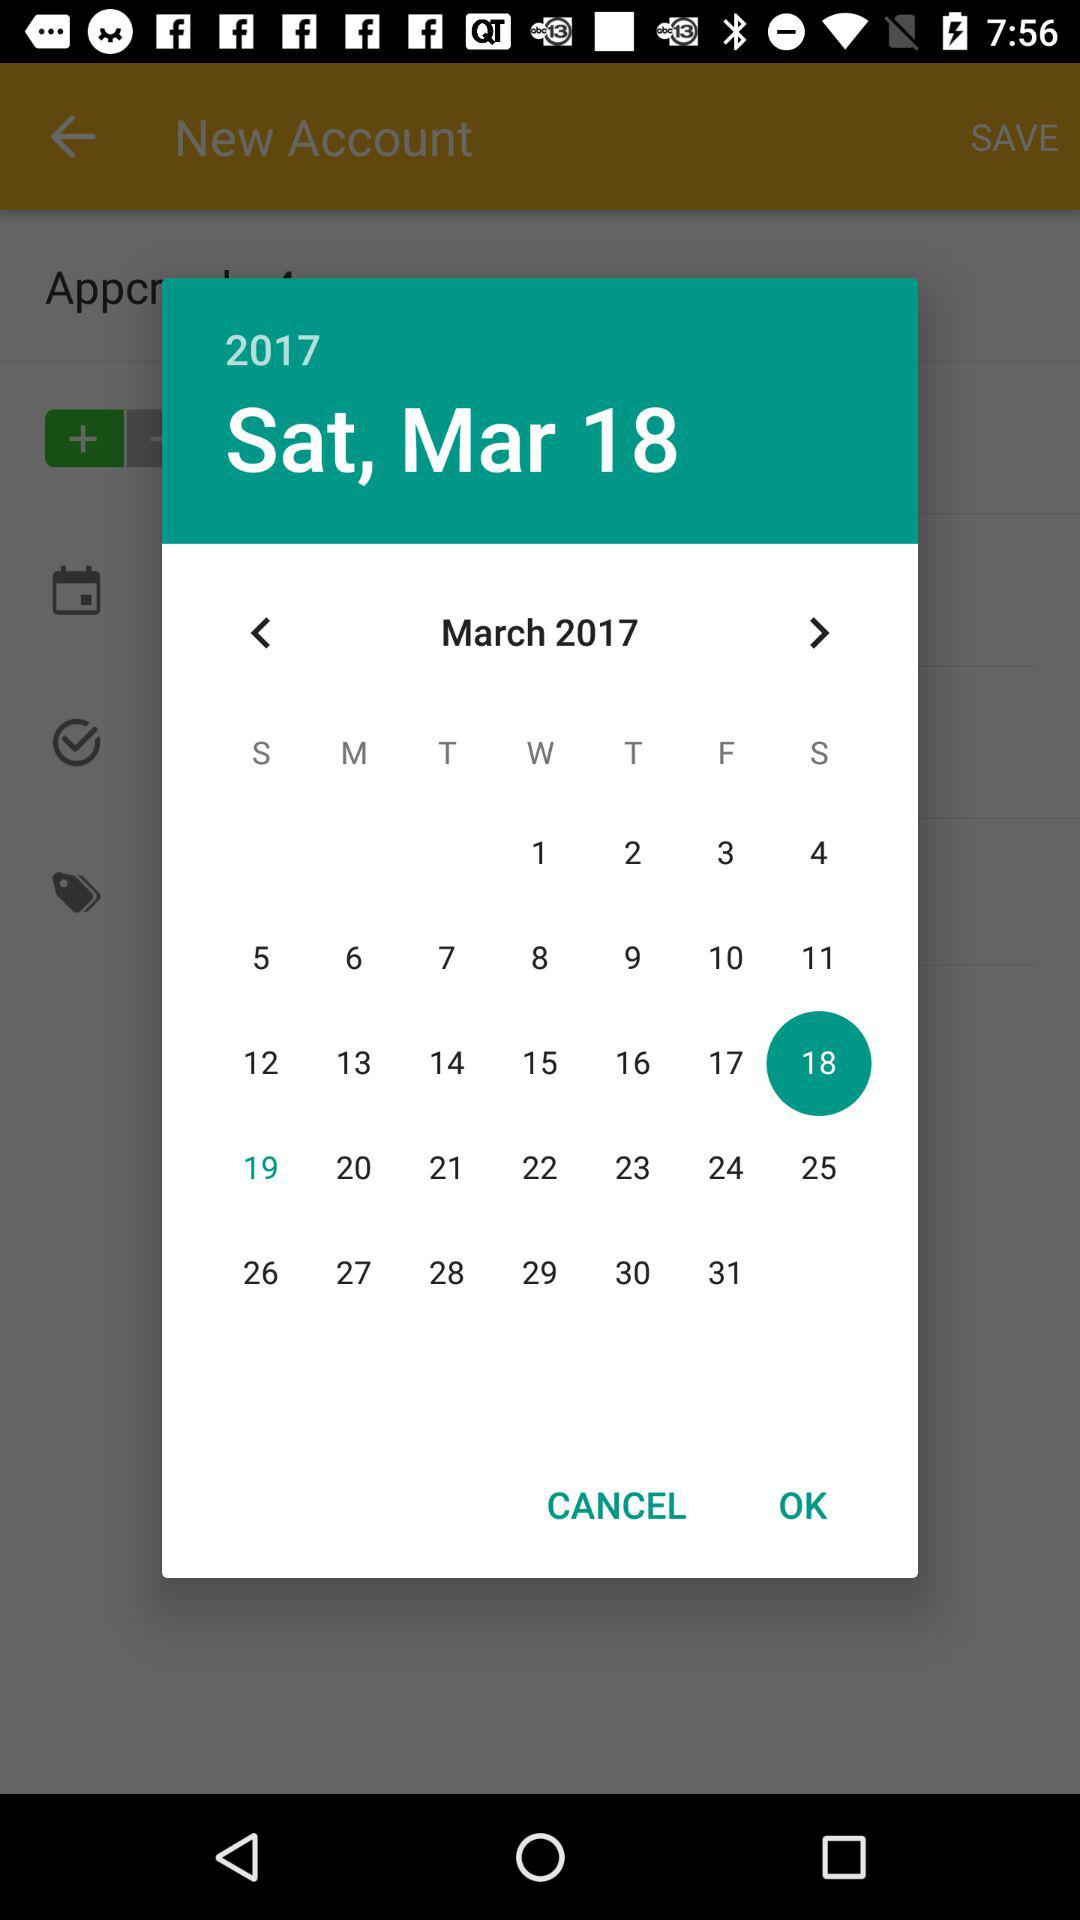How many months are represented in the calendar?
Answer the question using a single word or phrase. 12 